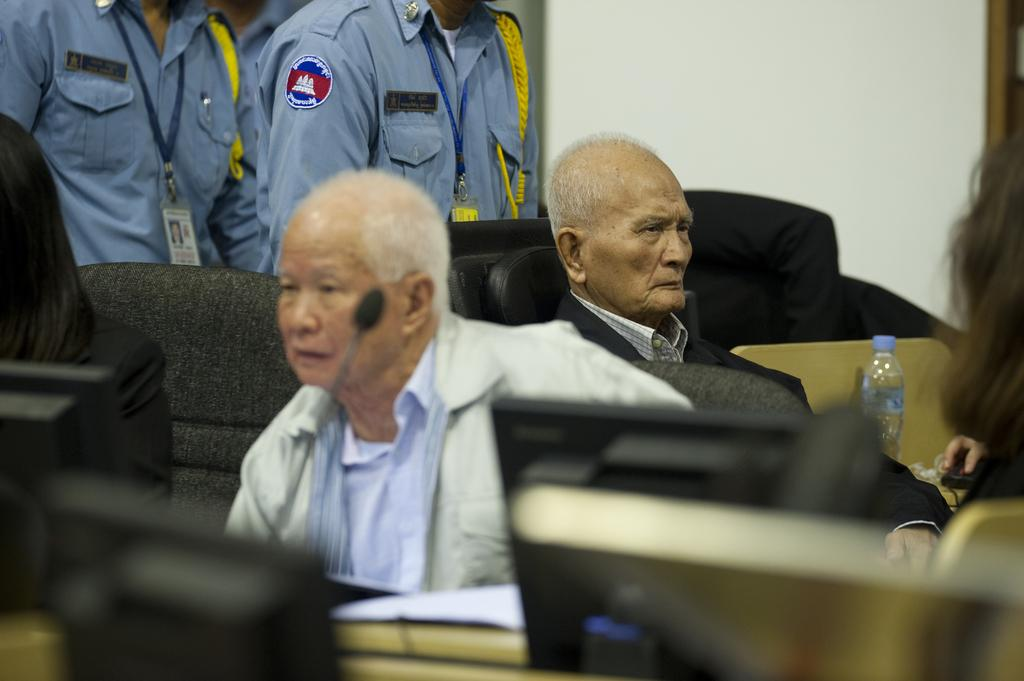How many people are in the image? There are people in the image, but the exact number is not specified. What are some of the people doing in the image? Some people are sitting on chairs in the image. What electronic devices can be seen in the image? There are laptops in the image. What other objects can be seen in the image? There is a bottle and a microphone in the image. What type of background is visible in the image? There is a wall visible in the image. What type of bells can be heard ringing in the image? There are no bells present in the image, and therefore no sound can be heard. What thoughts are the people in the image having? We cannot determine the thoughts of the people in the image based on the provided facts. --- 